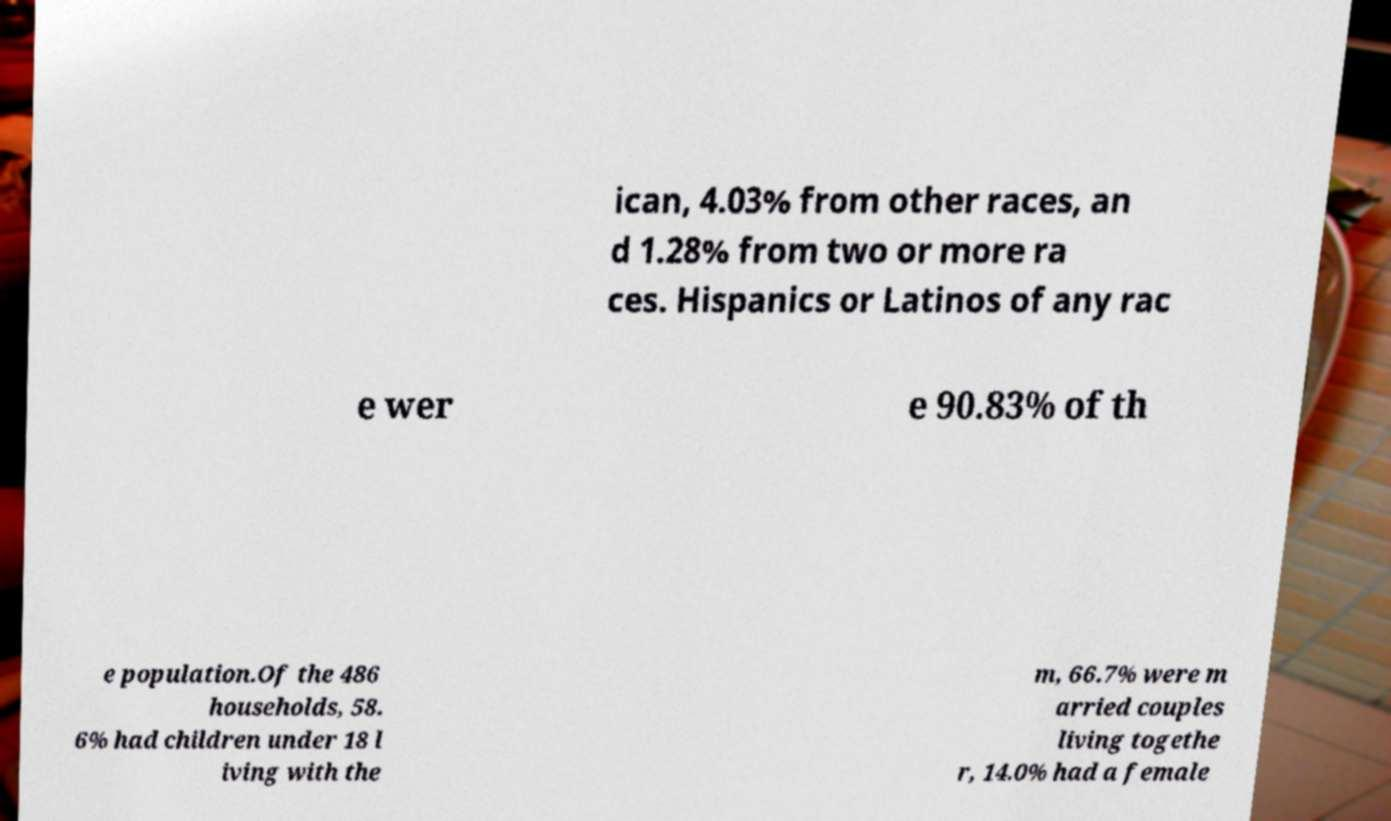I need the written content from this picture converted into text. Can you do that? ican, 4.03% from other races, an d 1.28% from two or more ra ces. Hispanics or Latinos of any rac e wer e 90.83% of th e population.Of the 486 households, 58. 6% had children under 18 l iving with the m, 66.7% were m arried couples living togethe r, 14.0% had a female 